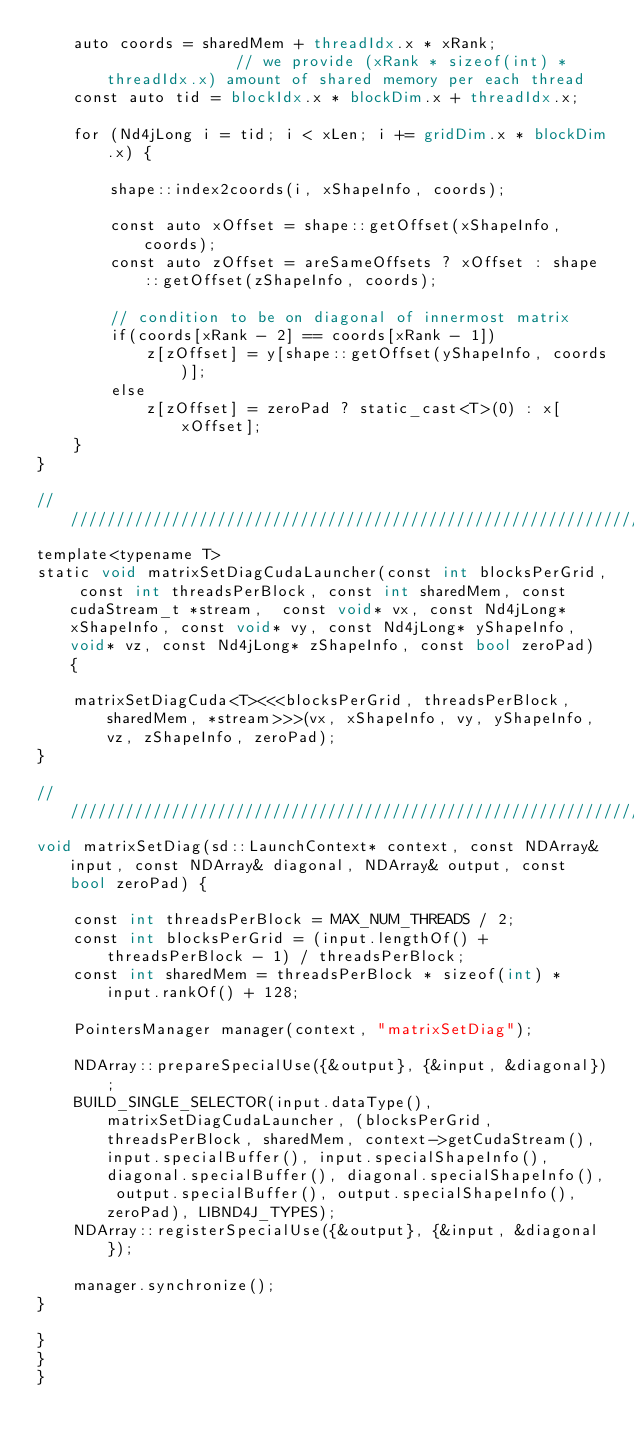Convert code to text. <code><loc_0><loc_0><loc_500><loc_500><_Cuda_>    auto coords = sharedMem + threadIdx.x * xRank;               // we provide (xRank * sizeof(int) * threadIdx.x) amount of shared memory per each thread
    const auto tid = blockIdx.x * blockDim.x + threadIdx.x;

    for (Nd4jLong i = tid; i < xLen; i += gridDim.x * blockDim.x) {

        shape::index2coords(i, xShapeInfo, coords);

        const auto xOffset = shape::getOffset(xShapeInfo, coords);
        const auto zOffset = areSameOffsets ? xOffset : shape::getOffset(zShapeInfo, coords);

        // condition to be on diagonal of innermost matrix
        if(coords[xRank - 2] == coords[xRank - 1])
            z[zOffset] = y[shape::getOffset(yShapeInfo, coords)];
        else
            z[zOffset] = zeroPad ? static_cast<T>(0) : x[xOffset];
    }
}

///////////////////////////////////////////////////////////////////
template<typename T>
static void matrixSetDiagCudaLauncher(const int blocksPerGrid, const int threadsPerBlock, const int sharedMem, const cudaStream_t *stream,  const void* vx, const Nd4jLong* xShapeInfo, const void* vy, const Nd4jLong* yShapeInfo, void* vz, const Nd4jLong* zShapeInfo, const bool zeroPad) {

    matrixSetDiagCuda<T><<<blocksPerGrid, threadsPerBlock, sharedMem, *stream>>>(vx, xShapeInfo, vy, yShapeInfo, vz, zShapeInfo, zeroPad);
}

///////////////////////////////////////////////////////////////////
void matrixSetDiag(sd::LaunchContext* context, const NDArray& input, const NDArray& diagonal, NDArray& output, const bool zeroPad) {

    const int threadsPerBlock = MAX_NUM_THREADS / 2;
    const int blocksPerGrid = (input.lengthOf() + threadsPerBlock - 1) / threadsPerBlock;
    const int sharedMem = threadsPerBlock * sizeof(int) * input.rankOf() + 128;

    PointersManager manager(context, "matrixSetDiag");

    NDArray::prepareSpecialUse({&output}, {&input, &diagonal});
    BUILD_SINGLE_SELECTOR(input.dataType(), matrixSetDiagCudaLauncher, (blocksPerGrid, threadsPerBlock, sharedMem, context->getCudaStream(), input.specialBuffer(), input.specialShapeInfo(), diagonal.specialBuffer(), diagonal.specialShapeInfo(), output.specialBuffer(), output.specialShapeInfo(), zeroPad), LIBND4J_TYPES);
    NDArray::registerSpecialUse({&output}, {&input, &diagonal});

    manager.synchronize();
}

}
}
}</code> 